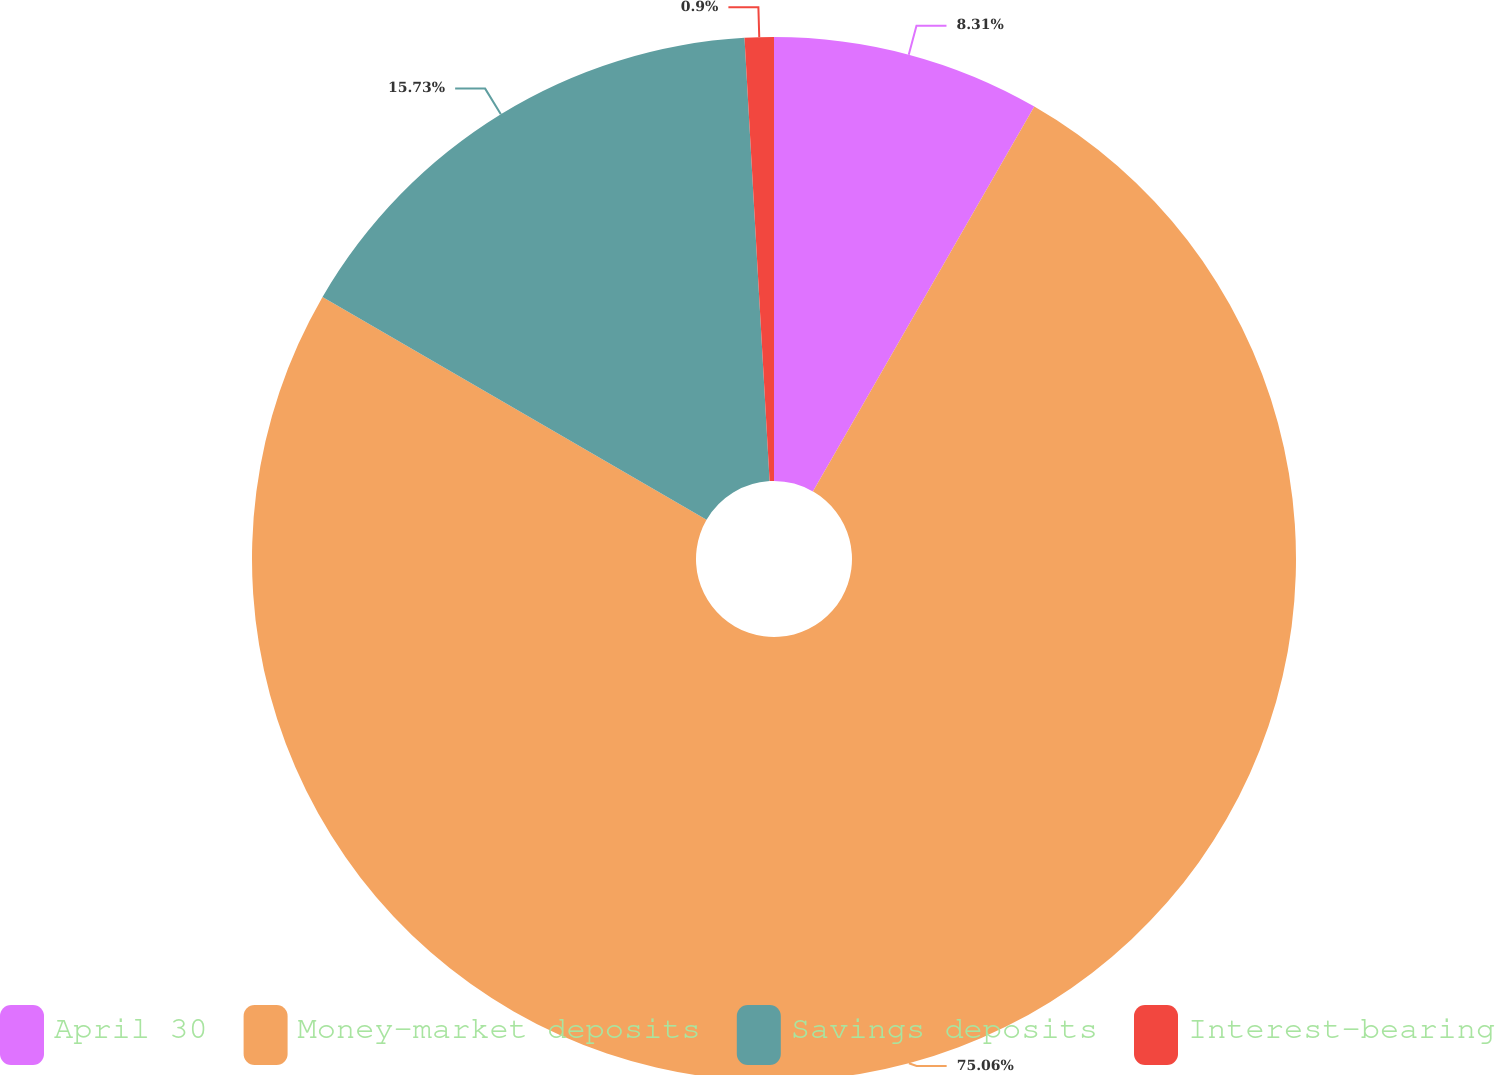Convert chart. <chart><loc_0><loc_0><loc_500><loc_500><pie_chart><fcel>April 30<fcel>Money-market deposits<fcel>Savings deposits<fcel>Interest-bearing<nl><fcel>8.31%<fcel>75.06%<fcel>15.73%<fcel>0.9%<nl></chart> 